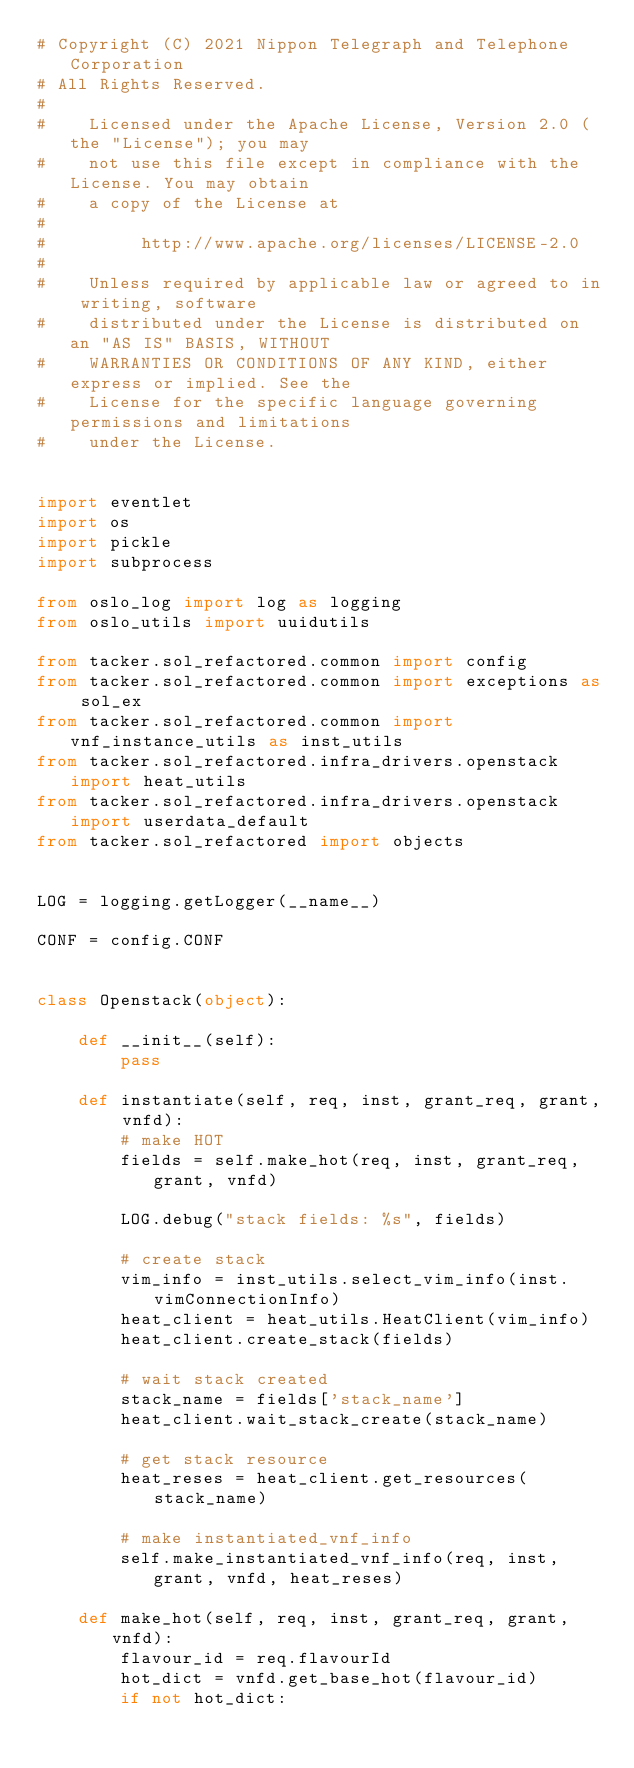Convert code to text. <code><loc_0><loc_0><loc_500><loc_500><_Python_># Copyright (C) 2021 Nippon Telegraph and Telephone Corporation
# All Rights Reserved.
#
#    Licensed under the Apache License, Version 2.0 (the "License"); you may
#    not use this file except in compliance with the License. You may obtain
#    a copy of the License at
#
#         http://www.apache.org/licenses/LICENSE-2.0
#
#    Unless required by applicable law or agreed to in writing, software
#    distributed under the License is distributed on an "AS IS" BASIS, WITHOUT
#    WARRANTIES OR CONDITIONS OF ANY KIND, either express or implied. See the
#    License for the specific language governing permissions and limitations
#    under the License.


import eventlet
import os
import pickle
import subprocess

from oslo_log import log as logging
from oslo_utils import uuidutils

from tacker.sol_refactored.common import config
from tacker.sol_refactored.common import exceptions as sol_ex
from tacker.sol_refactored.common import vnf_instance_utils as inst_utils
from tacker.sol_refactored.infra_drivers.openstack import heat_utils
from tacker.sol_refactored.infra_drivers.openstack import userdata_default
from tacker.sol_refactored import objects


LOG = logging.getLogger(__name__)

CONF = config.CONF


class Openstack(object):

    def __init__(self):
        pass

    def instantiate(self, req, inst, grant_req, grant, vnfd):
        # make HOT
        fields = self.make_hot(req, inst, grant_req, grant, vnfd)

        LOG.debug("stack fields: %s", fields)

        # create stack
        vim_info = inst_utils.select_vim_info(inst.vimConnectionInfo)
        heat_client = heat_utils.HeatClient(vim_info)
        heat_client.create_stack(fields)

        # wait stack created
        stack_name = fields['stack_name']
        heat_client.wait_stack_create(stack_name)

        # get stack resource
        heat_reses = heat_client.get_resources(stack_name)

        # make instantiated_vnf_info
        self.make_instantiated_vnf_info(req, inst, grant, vnfd, heat_reses)

    def make_hot(self, req, inst, grant_req, grant, vnfd):
        flavour_id = req.flavourId
        hot_dict = vnfd.get_base_hot(flavour_id)
        if not hot_dict:</code> 